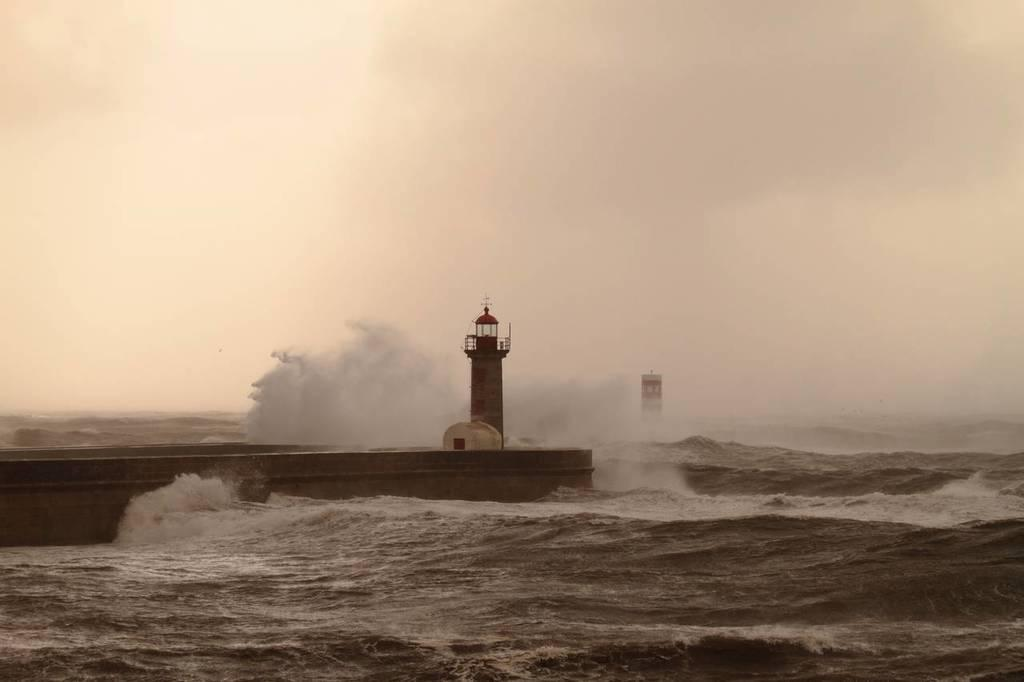What is located in the foreground of the image? There is a boat and a light tower in the foreground of the image. Where is the image set? The image is set in the ocean. What can be seen in the sky in the image? The sky is visible in the image. What is the source of the smoke visible in the image? The source of the smoke is not specified in the image. What type of birds can be seen flying in the image? There are no birds visible in the image. What is the value of the boat in the image? The value of the boat is not specified in the image. 